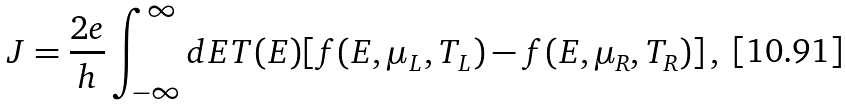<formula> <loc_0><loc_0><loc_500><loc_500>J = \frac { 2 e } { h } \int _ { - \infty } ^ { \infty } d E T ( E ) [ f ( E , \mu _ { L } , T _ { L } ) - f ( E , \mu _ { R } , T _ { R } ) ] \, ,</formula> 